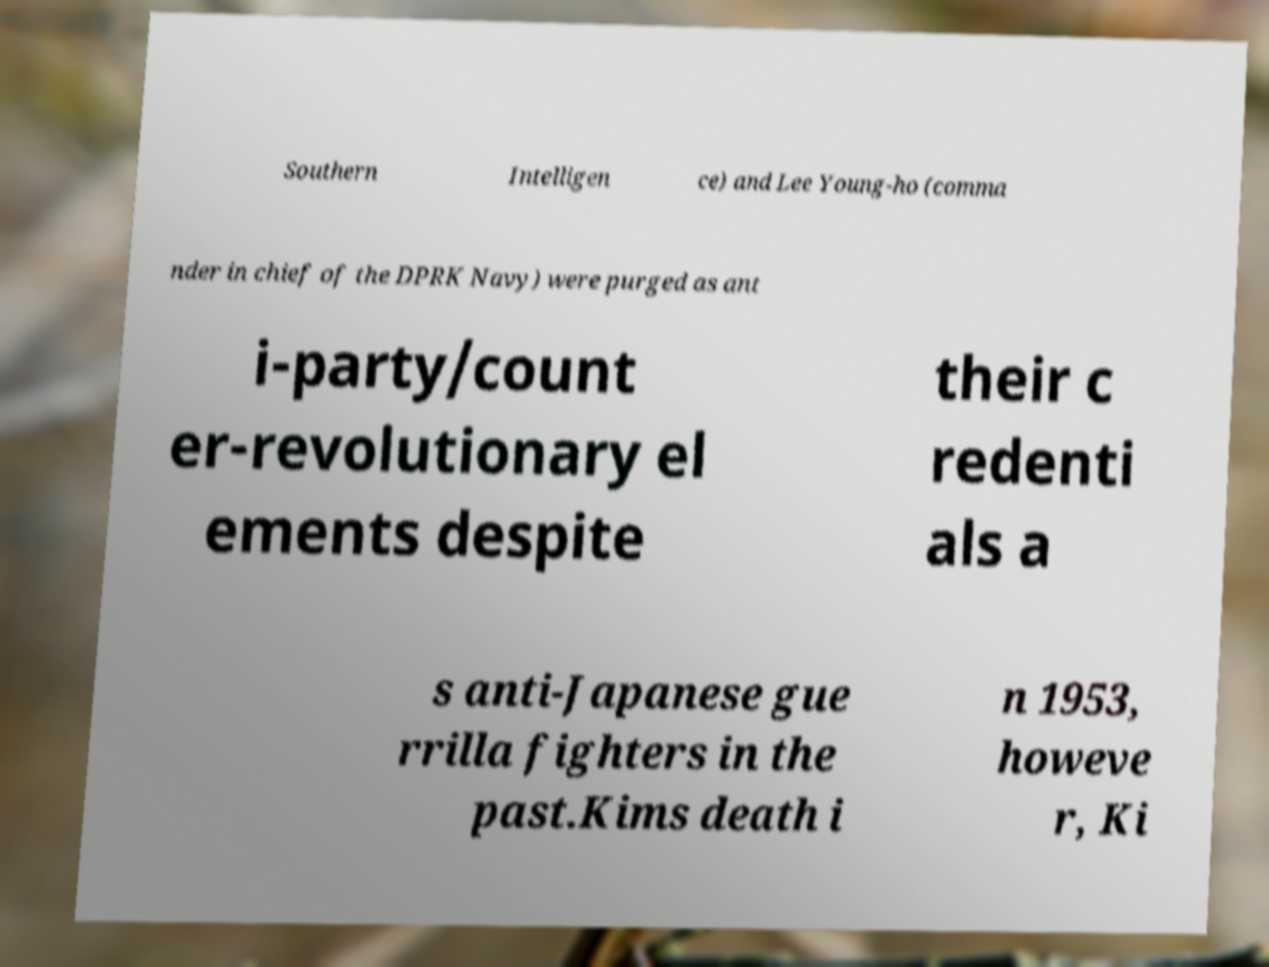Could you extract and type out the text from this image? Southern Intelligen ce) and Lee Young-ho (comma nder in chief of the DPRK Navy) were purged as ant i-party/count er-revolutionary el ements despite their c redenti als a s anti-Japanese gue rrilla fighters in the past.Kims death i n 1953, howeve r, Ki 